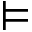<formula> <loc_0><loc_0><loc_500><loc_500>\models</formula> 